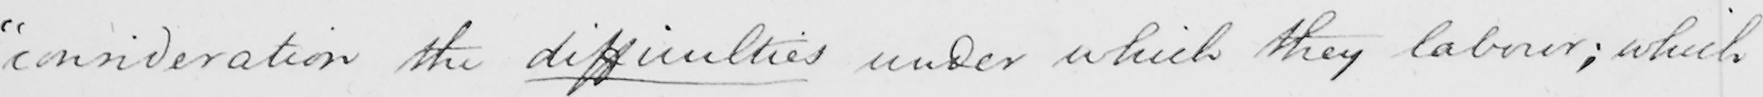What is written in this line of handwriting? " consideration the difficulties under which they labour ; which 